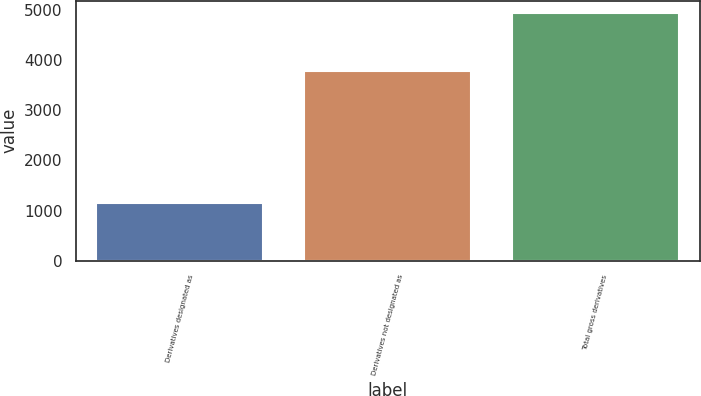Convert chart. <chart><loc_0><loc_0><loc_500><loc_500><bar_chart><fcel>Derivatives designated as<fcel>Derivatives not designated as<fcel>Total gross derivatives<nl><fcel>1159<fcel>3782<fcel>4941<nl></chart> 